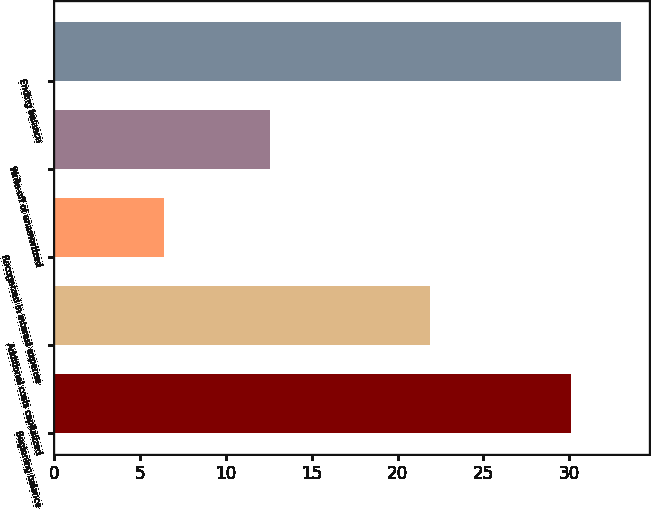<chart> <loc_0><loc_0><loc_500><loc_500><bar_chart><fcel>Beginning balance<fcel>Additional costs capitalized<fcel>Recognized in interest expense<fcel>Write-off of unamortized<fcel>Ending balance<nl><fcel>30.1<fcel>21.9<fcel>6.4<fcel>12.6<fcel>33<nl></chart> 